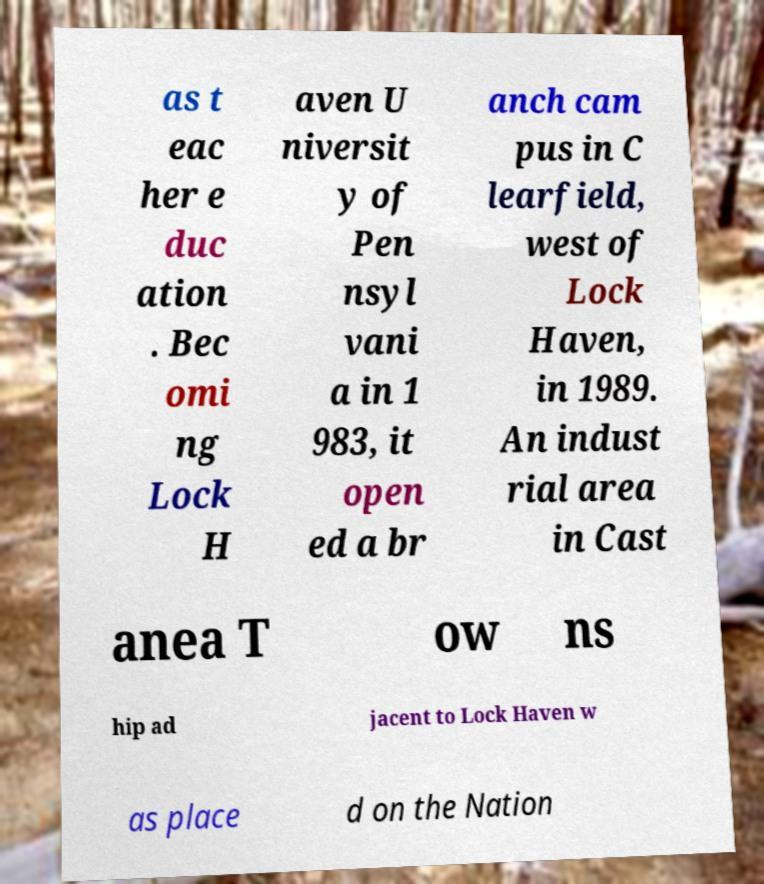Please read and relay the text visible in this image. What does it say? as t eac her e duc ation . Bec omi ng Lock H aven U niversit y of Pen nsyl vani a in 1 983, it open ed a br anch cam pus in C learfield, west of Lock Haven, in 1989. An indust rial area in Cast anea T ow ns hip ad jacent to Lock Haven w as place d on the Nation 